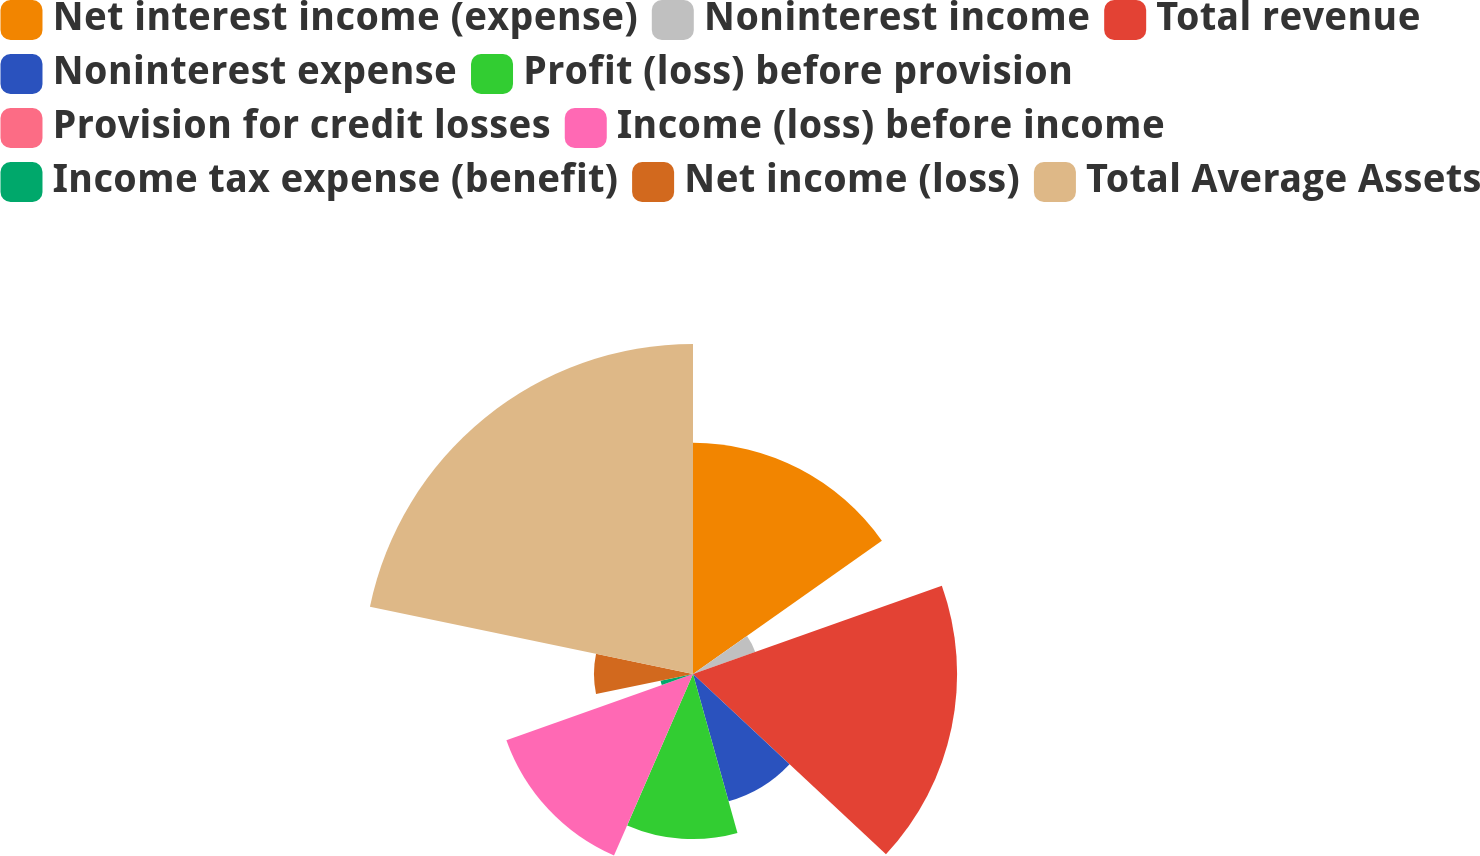<chart> <loc_0><loc_0><loc_500><loc_500><pie_chart><fcel>Net interest income (expense)<fcel>Noninterest income<fcel>Total revenue<fcel>Noninterest expense<fcel>Profit (loss) before provision<fcel>Provision for credit losses<fcel>Income (loss) before income<fcel>Income tax expense (benefit)<fcel>Net income (loss)<fcel>Total Average Assets<nl><fcel>15.22%<fcel>4.35%<fcel>17.39%<fcel>8.7%<fcel>10.87%<fcel>0.0%<fcel>13.04%<fcel>2.18%<fcel>6.52%<fcel>21.73%<nl></chart> 